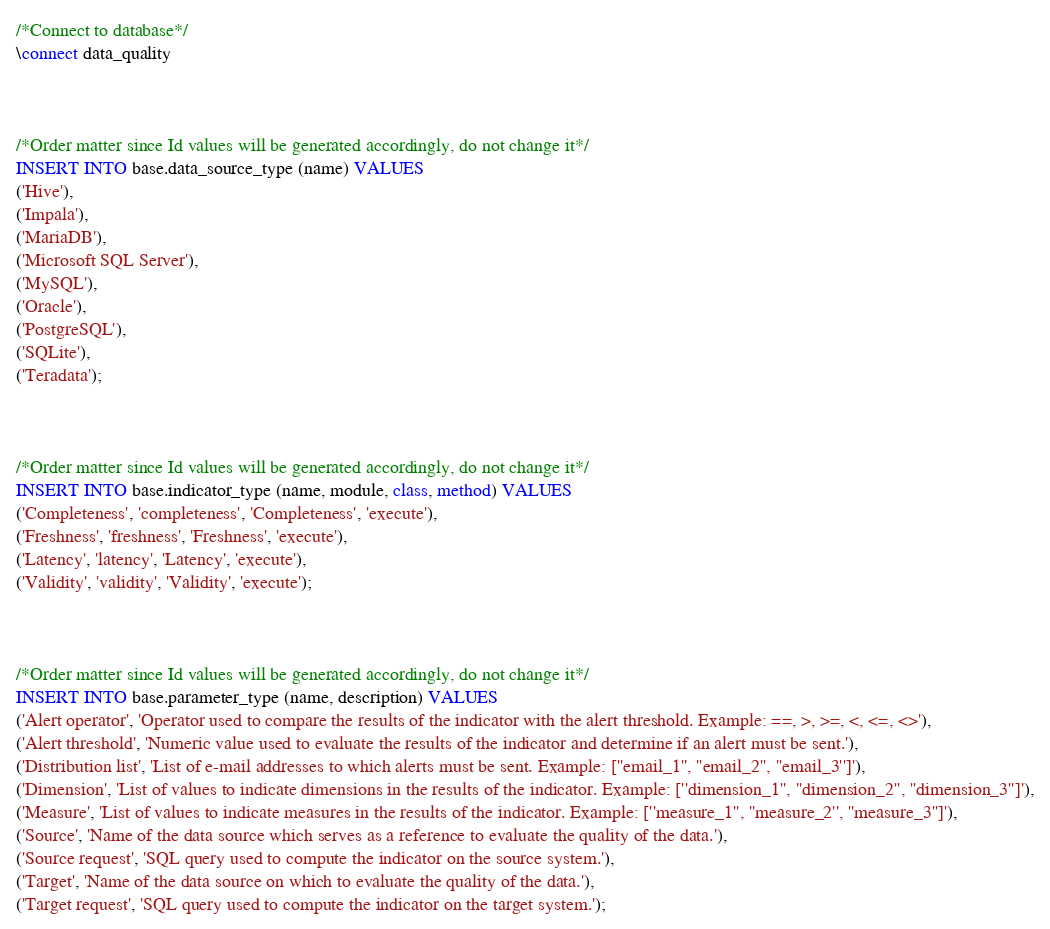Convert code to text. <code><loc_0><loc_0><loc_500><loc_500><_SQL_>/*Connect to database*/
\connect data_quality



/*Order matter since Id values will be generated accordingly, do not change it*/
INSERT INTO base.data_source_type (name) VALUES
('Hive'),
('Impala'),
('MariaDB'),
('Microsoft SQL Server'),
('MySQL'),
('Oracle'),
('PostgreSQL'),
('SQLite'),
('Teradata');



/*Order matter since Id values will be generated accordingly, do not change it*/
INSERT INTO base.indicator_type (name, module, class, method) VALUES
('Completeness', 'completeness', 'Completeness', 'execute'),
('Freshness', 'freshness', 'Freshness', 'execute'),
('Latency', 'latency', 'Latency', 'execute'),
('Validity', 'validity', 'Validity', 'execute');



/*Order matter since Id values will be generated accordingly, do not change it*/
INSERT INTO base.parameter_type (name, description) VALUES
('Alert operator', 'Operator used to compare the results of the indicator with the alert threshold. Example: ==, >, >=, <, <=, <>'),
('Alert threshold', 'Numeric value used to evaluate the results of the indicator and determine if an alert must be sent.'),
('Distribution list', 'List of e-mail addresses to which alerts must be sent. Example: [''email_1'', ''email_2'', ''email_3'']'),
('Dimension', 'List of values to indicate dimensions in the results of the indicator. Example: [''dimension_1'', ''dimension_2'', ''dimension_3'']'),
('Measure', 'List of values to indicate measures in the results of the indicator. Example: [''measure_1'', ''measure_2'', ''measure_3'']'),
('Source', 'Name of the data source which serves as a reference to evaluate the quality of the data.'),
('Source request', 'SQL query used to compute the indicator on the source system.'),
('Target', 'Name of the data source on which to evaluate the quality of the data.'),
('Target request', 'SQL query used to compute the indicator on the target system.');
</code> 